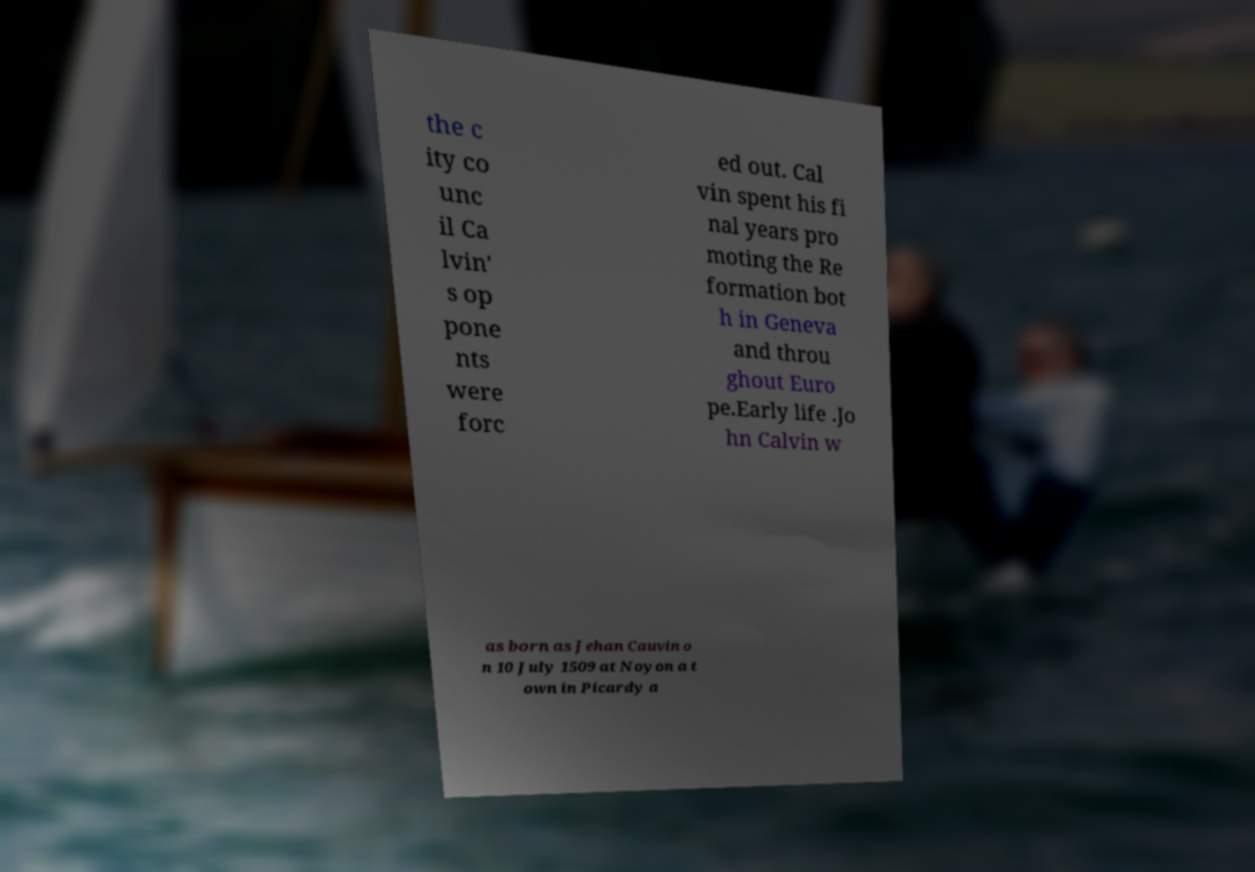Can you accurately transcribe the text from the provided image for me? the c ity co unc il Ca lvin' s op pone nts were forc ed out. Cal vin spent his fi nal years pro moting the Re formation bot h in Geneva and throu ghout Euro pe.Early life .Jo hn Calvin w as born as Jehan Cauvin o n 10 July 1509 at Noyon a t own in Picardy a 